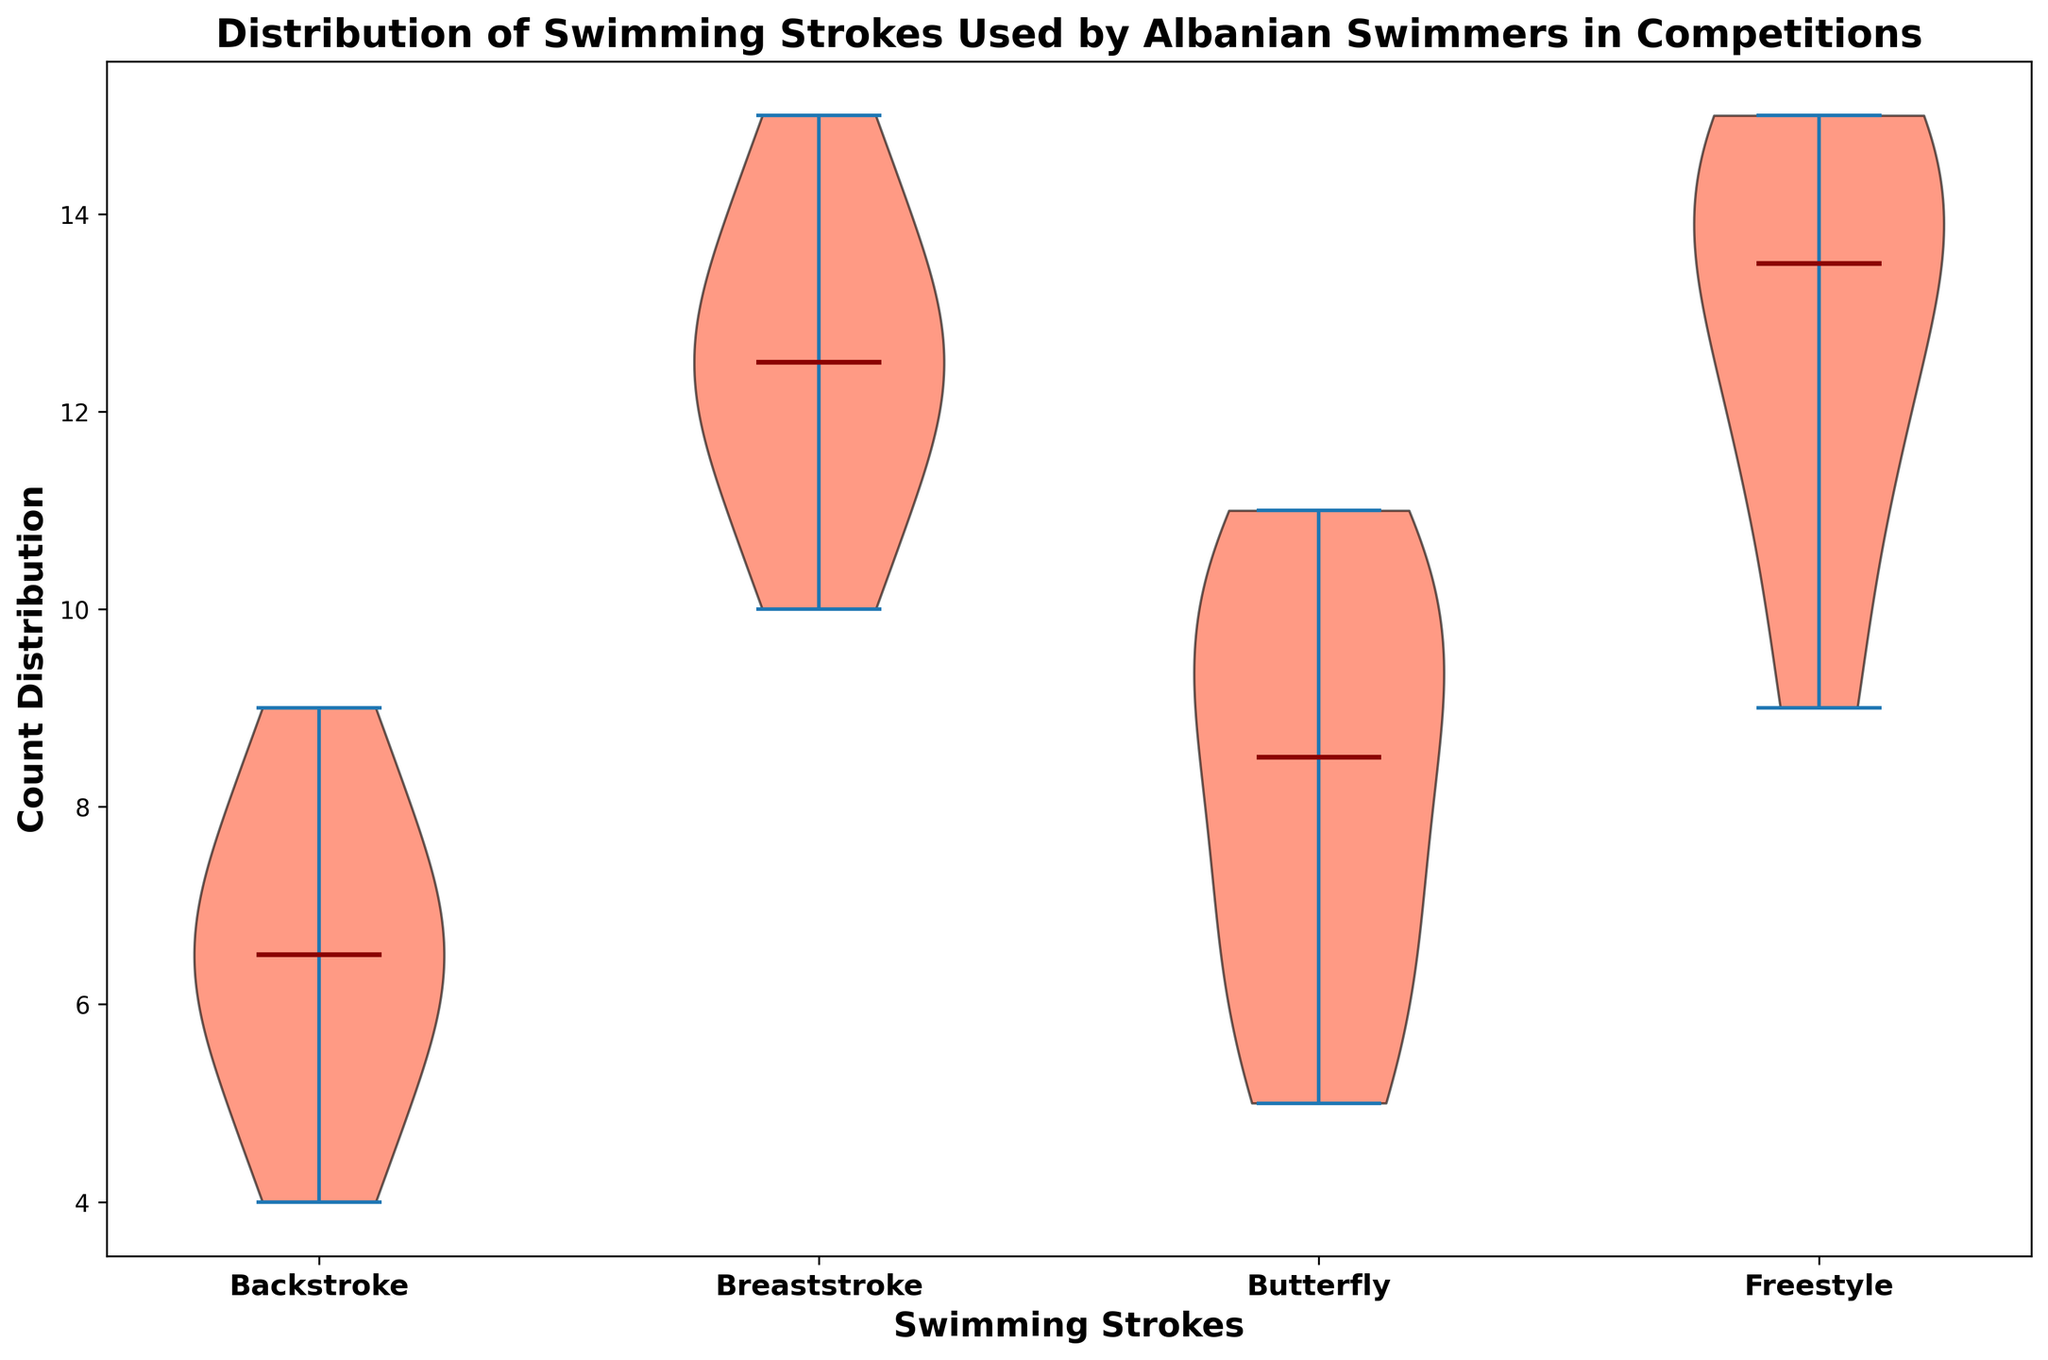What is the median count for Freestyle? To find the median, we need to look at the central value when the counts for Freestyle are ordered. The ordered counts for Freestyle are [9, 11, 12, 13, 14, 14, 15, 15]. The median is the average of the 4th and 5th values, which is (13+14)/2 = 13.5
Answer: 13.5 Which stroke has the highest median count? The medians are shown by the central lines in each plot. By looking at the central lines, the highest median appears in the Breaststroke group.
Answer: Breaststroke Does the Backstroke have a higher or lower median than the Butterfly? We compare the central lines in the violin plots. The median line for Backstroke is lower than that for Butterfly.
Answer: Lower Which swimming stroke has the widest spread (range)? By comparing the width of each violin plot, we can see that Freestyle has the widest spread of counts, indicating a large range.
Answer: Freestyle What is the mean count for Breaststroke? Sum the counts for Breaststroke: (12+11+10+14+13+15+12+13) = 100. There are 8 data points, so the mean is 100/8 = 12.5
Answer: 12.5 How does the median of Backstroke compare to that of Freestyle? By comparing the central lines, we see that the median for Backstroke is lower than that for Freestyle.
Answer: Lower Which stroke has the smallest range of counts? The smallest range can be observed in Backstroke, where the spread of the violin plot is narrowest.
Answer: Backstroke What color are the bodies of the violin plots? The violin plots are filled with an orange/red color.
Answer: Orange/red What operation is shown by the thick line in the center of each violin plot? The thick line represents the median of the counts for each swimming stroke.
Answer: Median Is the median count for Butterfly closer to that of Breaststroke or Backstroke? The median line in Butterfly is closer in value to that of Breaststroke than to Backstroke.
Answer: Breaststroke 